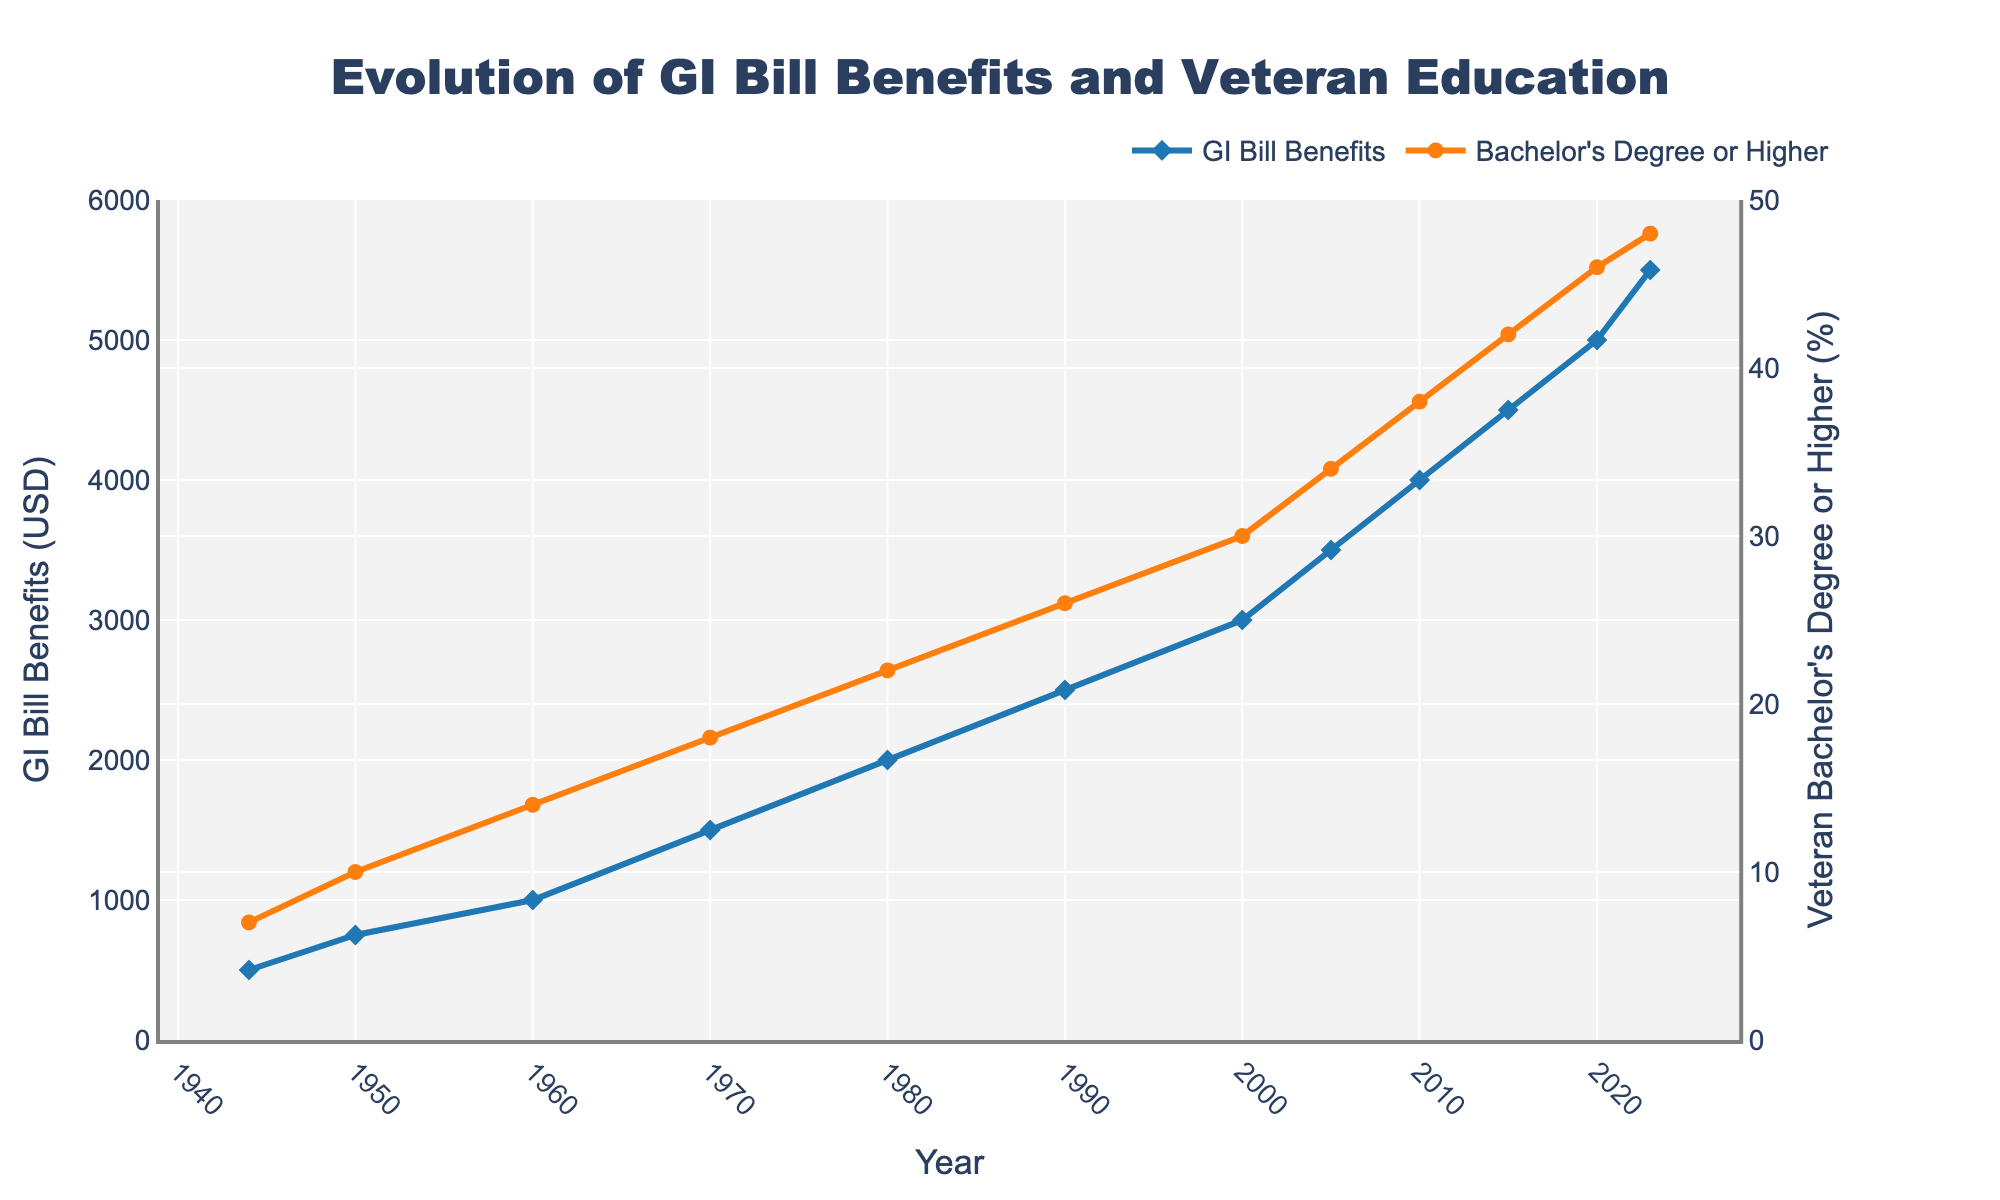Which year saw the highest percentage of veterans with a bachelor's degree or higher? By examining the figure, the highest point on the line representing the percentage of veterans with a bachelor's degree or higher occurs in 2023.
Answer: 2023 What was the increase in GI Bill benefits from 1944 to 2023? The GI Bill benefits in 1944 were 500 USD, and in 2023, they were 5500 USD. The increase is calculated as 5500 - 500.
Answer: 5000 USD Between 1970 and 1980, did the percentage of veterans with a bachelor's degree or higher increase or decrease? Checking the figure, in 1970, the percentage was 18%, and in 1980, it was 22%. Since 22% is greater than 18%, there was an increase.
Answer: Increase How much did the percentage of veterans with a bachelor's degree or higher increase between 1990 and 2000? In 1990, the percentage was 26%, and in 2000, it was 30%. The increase is calculated as 30% - 26%.
Answer: 4% Which color represents the GI Bill benefits trend line? The trend line representing the GI Bill benefits is drawn in a distinguishable blue color.
Answer: Blue By how much did the GI Bill benefits increase between 2000 and 2010? The GI Bill benefits in 2000 were 3000 USD, and in 2010, they were 4000 USD. The increase is calculated as 4000 - 3000.
Answer: 1000 USD What visual marker is used to represent the percentage of veterans with a bachelor's degree or higher? The visual markers for the percentage of veterans with a bachelor's degree or higher are indicated by circles.
Answer: Circles What is the average GI Bill benefits amount shown for the years 1944 to 2023? Summing up the GI Bill benefits across all the years: 500 + 750 + 1000 + 1500 + 2000 + 2500 + 3000 + 3500 + 4000 + 4500 + 5000 + 5500 = 36750. There are 12 data points, so the average is 36750 / 12.
Answer: 3062.5 USD 